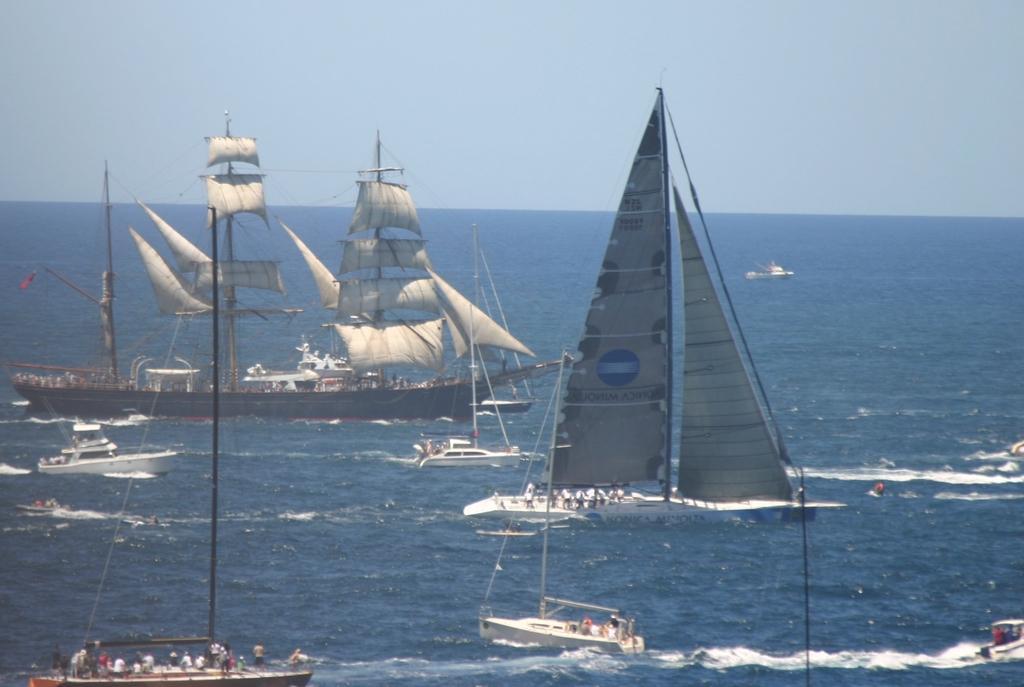In one or two sentences, can you explain what this image depicts? In this image I can see few ships and few people are inside the ships. I can see a white cloth on the poles and blue water. The sky is in blue color. 